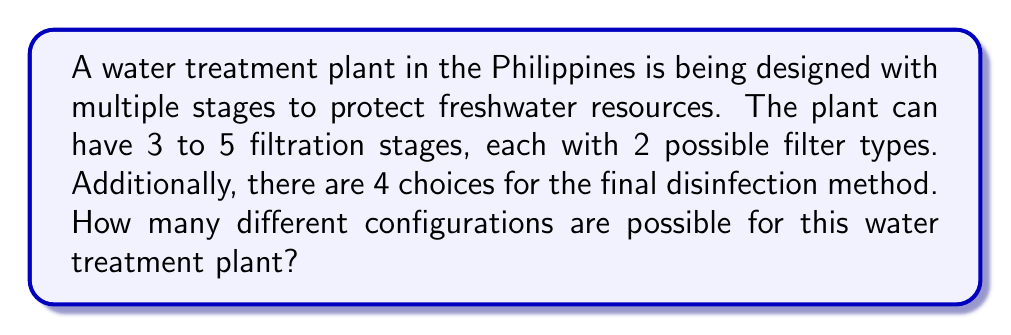Help me with this question. Let's break this down step-by-step:

1) First, we need to consider the number of possibilities for the filtration stages:
   - The plant can have 3, 4, or 5 stages
   - Each stage has 2 possible filter types

2) For each number of stages, we can calculate the number of possibilities:
   - 3 stages: $2^3 = 8$ possibilities
   - 4 stages: $2^4 = 16$ possibilities
   - 5 stages: $2^5 = 32$ possibilities

3) The total number of filtration configurations is the sum of these:
   $8 + 16 + 32 = 56$

4) Now, for each of these 56 filtration configurations, there are 4 choices for the final disinfection method.

5) To get the total number of possible configurations, we multiply the number of filtration configurations by the number of disinfection choices:

   $56 \times 4 = 224$

Therefore, there are 224 possible configurations for the water treatment plant.
Answer: 224 